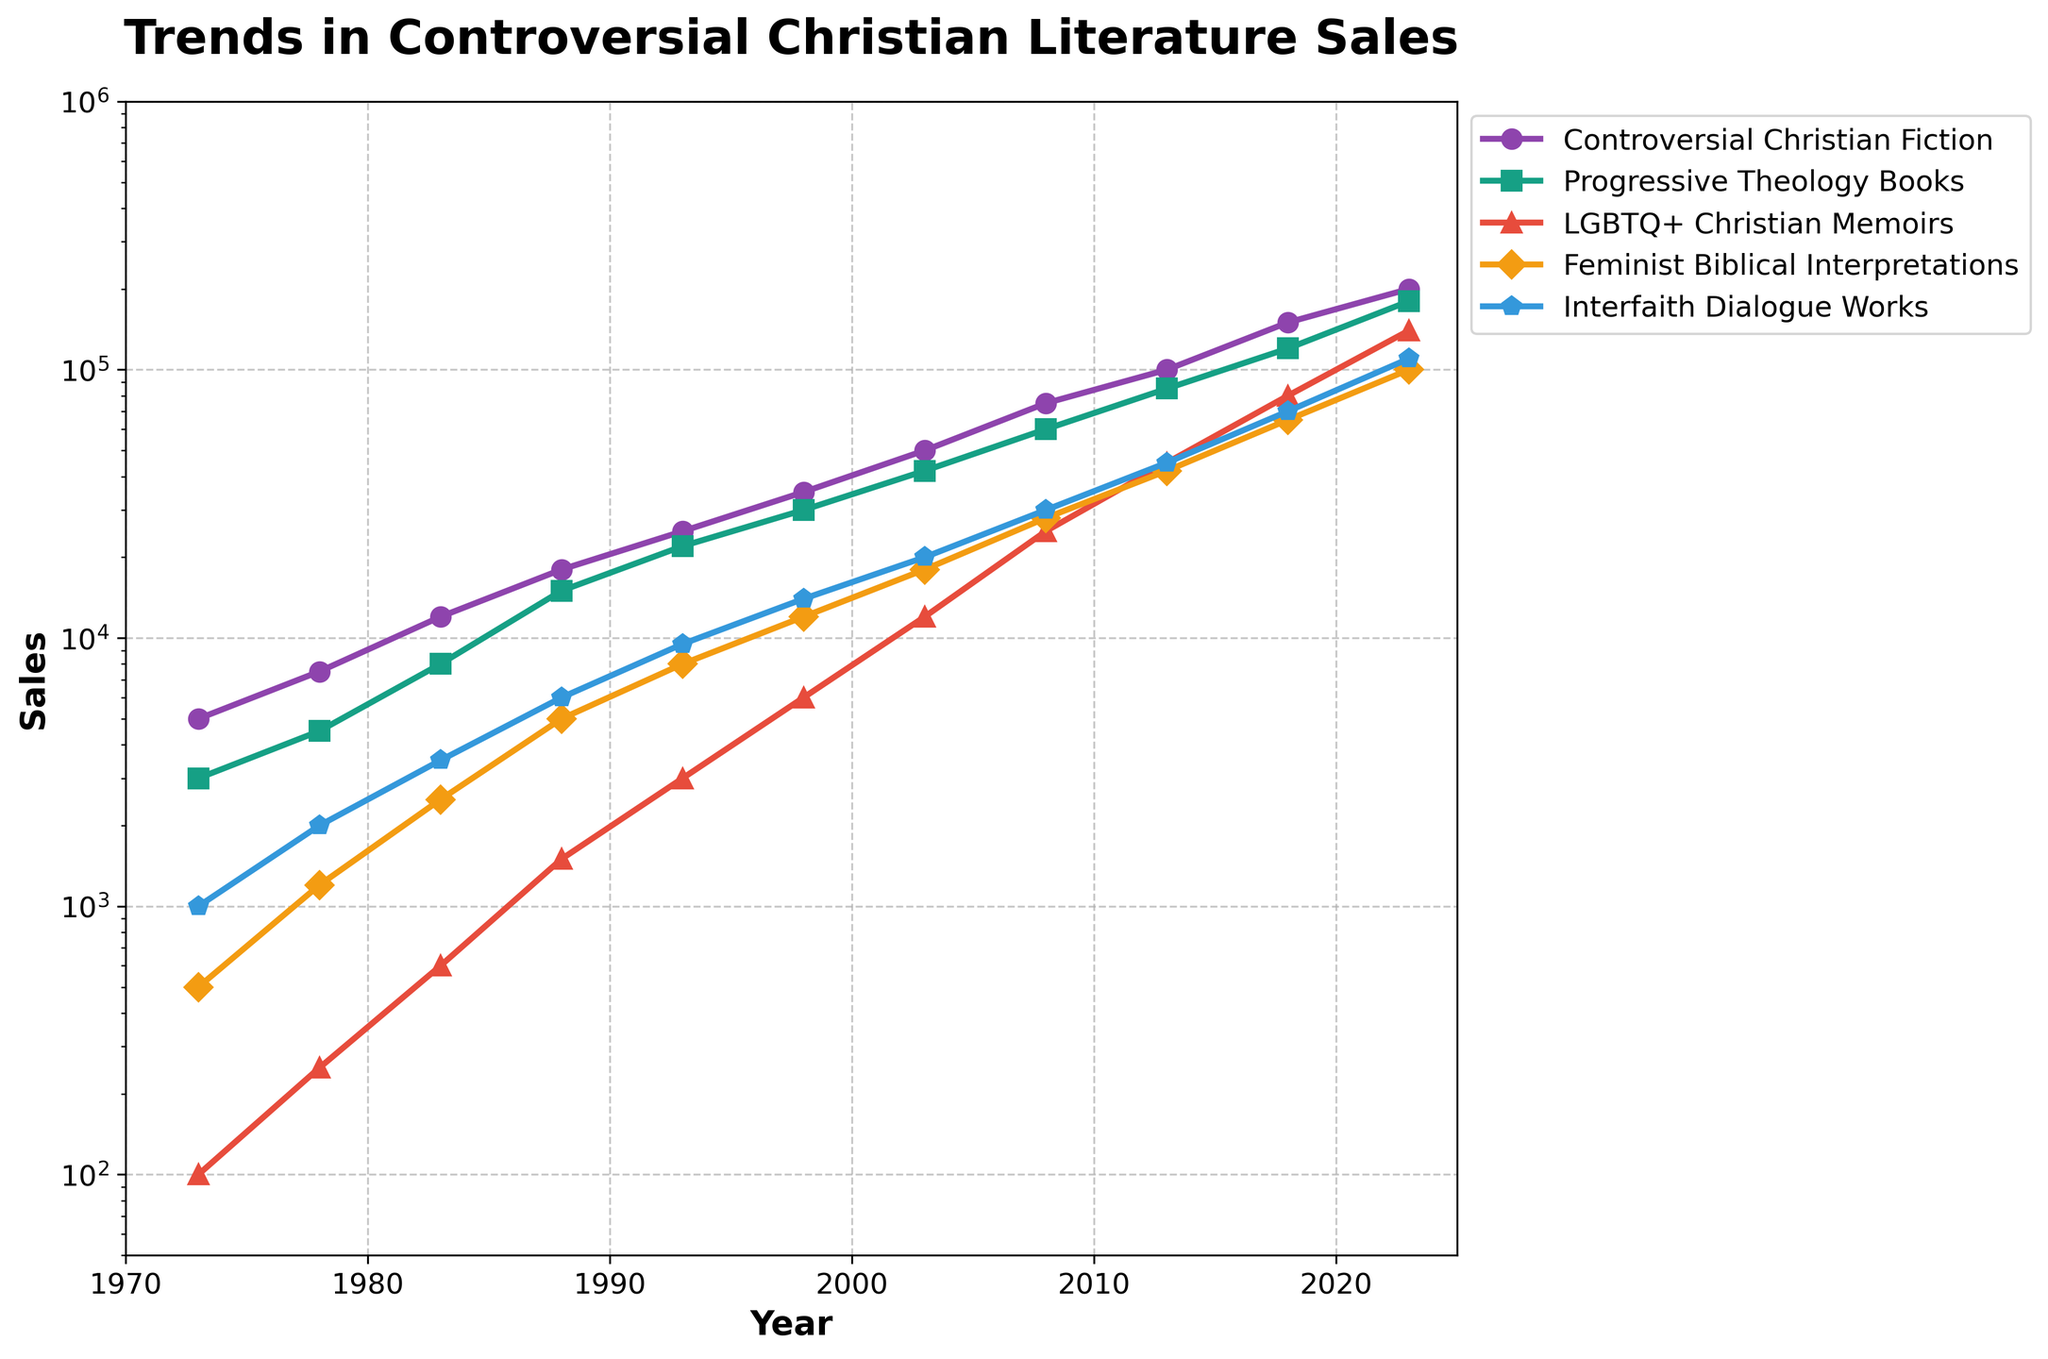What year did LGBTQ+ Christian Memoirs first reach 10,000 in sales? Identify and look at the sales trend for LGBTQ+ Christian Memoirs. The sales first reached 10,000 in 2013.
Answer: 2013 Between 1993 and 2003, which category had the largest increase in sales? Determine the increase in sales for each category between those years: Controversial Christian Fiction (25000), Progressive Theology Books (20000), LGBTQ+ Christian Memoirs (9000), Feminist Biblical Interpretations (10000), Interfaith Dialogue Works (10500). The largest increase was for Controversial Christian Fiction.
Answer: Controversial Christian Fiction Which category had the steepest rise in sales between 2013 and 2023? Compare the sales increase in each category during these years: Controversial Christian Fiction (100000), Progressive Theology Books (95000), LGBTQ+ Christian Memoirs (95000), Feminist Biblical Interpretations (58000), Interfaith Dialogue Works (65000). The steepest rise is seen in LGBTQ+ Christian Memoirs and Progressive Theology Books.
Answer: LGBTQ+ Christian Memoirs, Progressive Theology Books What were the sales figures for Controversial Christian Fiction and Progressive Theology Books in 1973, and what was their combined sales total? Look at the data points for these categories in 1973. Add the sales figures: 5000 + 3000 = 8000.
Answer: 8000 By how much did Feminist Biblical Interpretations sales increase from 1978 to 1983? Subtraction of sales figures: 2500 - 1200 = 1300.
Answer: 1300 In which year did Interfaith Dialogue Works surpass Feminist Biblical Interpretations in sales? Compare the sales figures of both categories year by year. In 1988, Interfaith Dialogue Works (6000) surpassed Feminist Biblical Interpretations (5000).
Answer: 1988 How many years did it take for Progressive Theology Books to go from 8000 in sales to 120000? Find the years with these sales figures and calculate the difference: 2018 - 1983 = 35 years.
Answer: 35 Which category had the highest sales in 2023? Look at the sales figures for 2023 for all categories. The highest sales are for Controversial Christian Fiction (200000).
Answer: Controversial Christian Fiction How much did the sales of LGBTQ+ Christian Memoirs increase between 1998 and 2008? Subtraction of sales figures: 25000 - 6000 = 19000.
Answer: 19000 Which category consistently had the lowest sales from 1973 to 1988? Compare the sales figures for all categories each year. LGBTQ+ Christian Memoirs had the lowest sales.
Answer: LGBTQ+ Christian Memoirs 